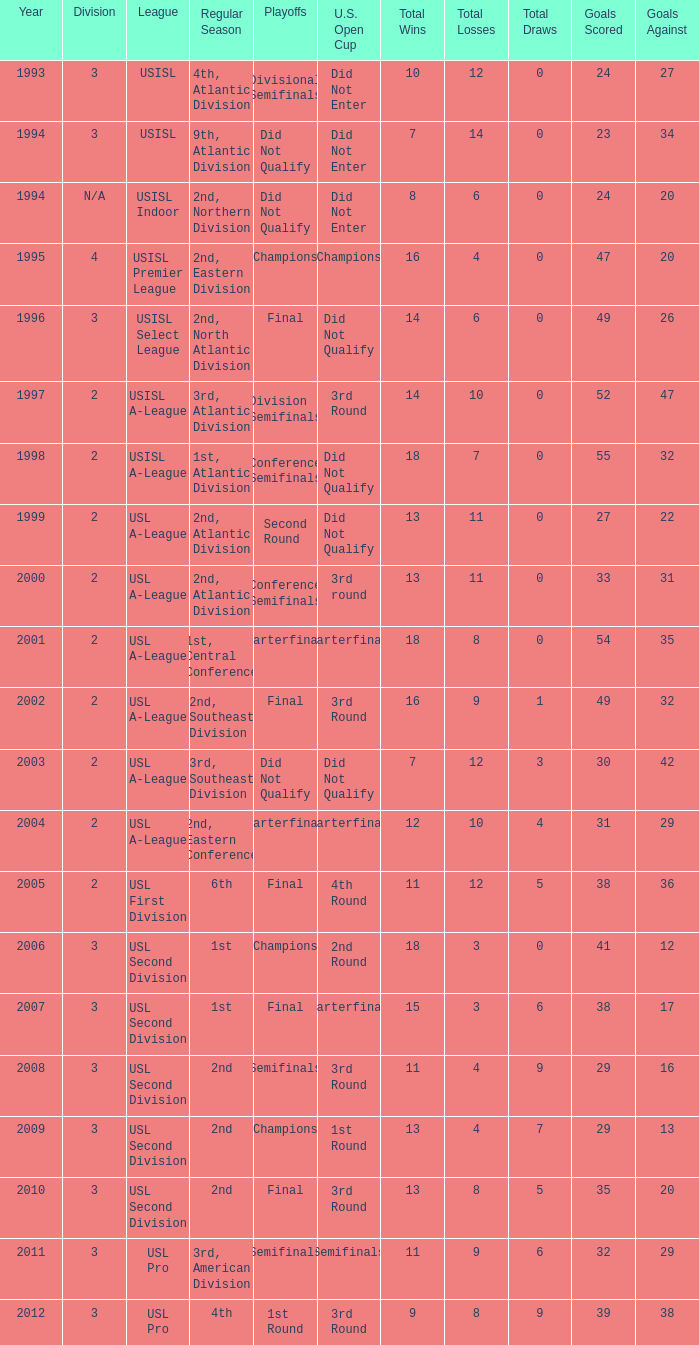What are all the playoffs for u.s. open cup in 1st round Champions. 